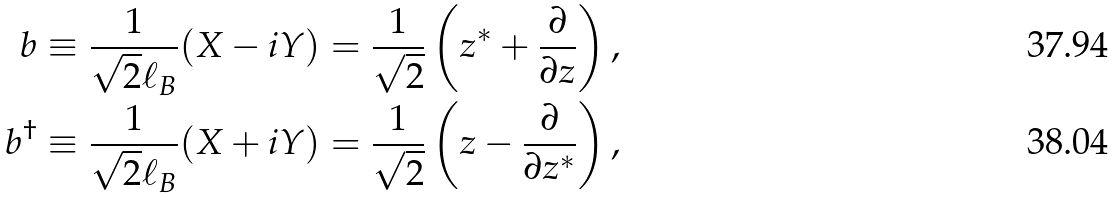Convert formula to latex. <formula><loc_0><loc_0><loc_500><loc_500>b \equiv \frac { 1 } { \sqrt { 2 } \ell _ { B } } ( X - i Y ) = { \frac { 1 } { \sqrt { 2 } } } \left ( z ^ { * } + { \frac { \partial } { \partial z } } \right ) , \\ b ^ { \dagger } \equiv \frac { 1 } { \sqrt { 2 } \ell _ { B } } ( X + i Y ) = { \frac { 1 } { \sqrt { 2 } } } \left ( z - { \frac { \partial } { \partial z ^ { * } } } \right ) ,</formula> 